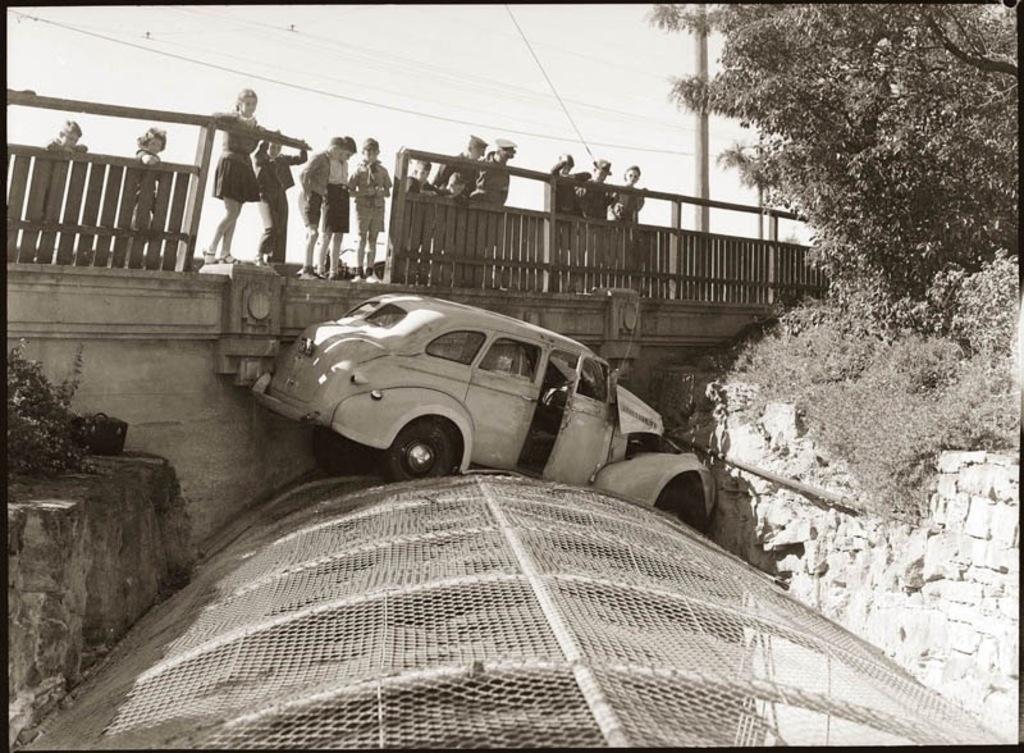Describe this image in one or two sentences. This picture is a black and white image. There is one car on the surface which looks like a net, one black object on the wall on the left side of the image, one bridge, some people standing on the bridge, some children standing on the bridge, some wires, some poles, one object at the bridge, some people holding the bridge, some plants with trees, some trees, plants and bushes on the ground. At the top there is the sky. 